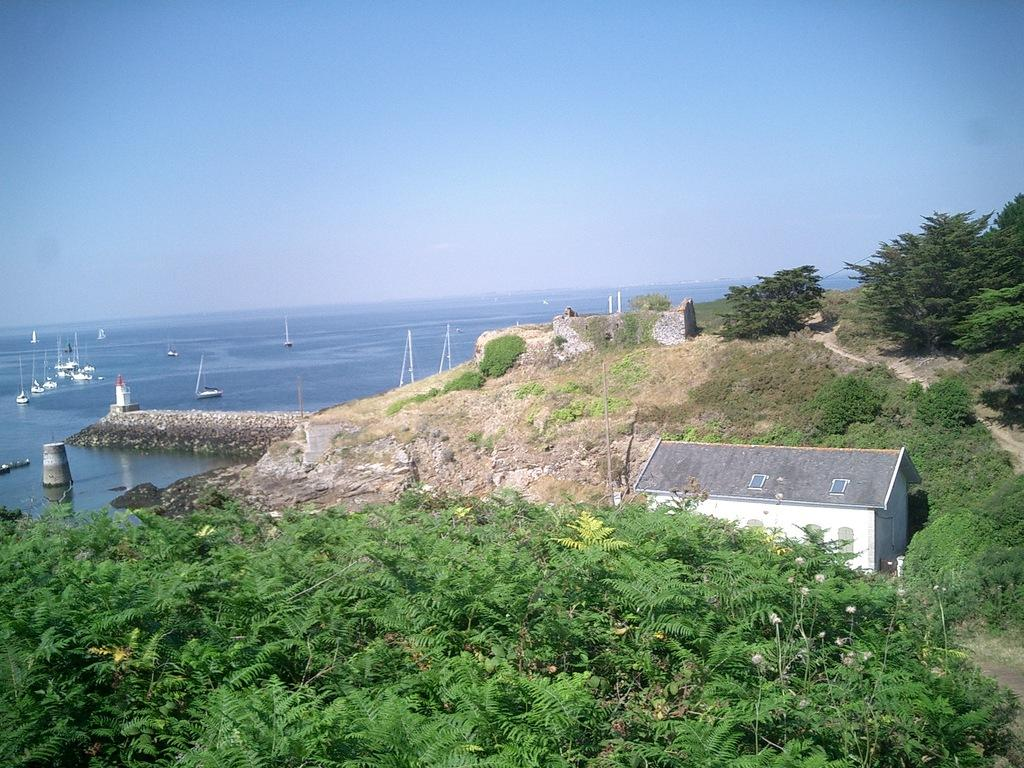What can be seen in the middle of the image? There are trees, houses, and poles in the middle of the image. What is visible behind the trees, houses, and poles? There is water visible behind the trees, houses, and poles. What is floating on the water? There are ships visible above the water. What is visible at the top of the image? The sky is visible at the top of the image. Can you see a squirrel wearing lace on one of the trees in the image? There is no squirrel or lace present on any of the trees in the image. Is the queen visible in the image? There is no queen present in the image. 